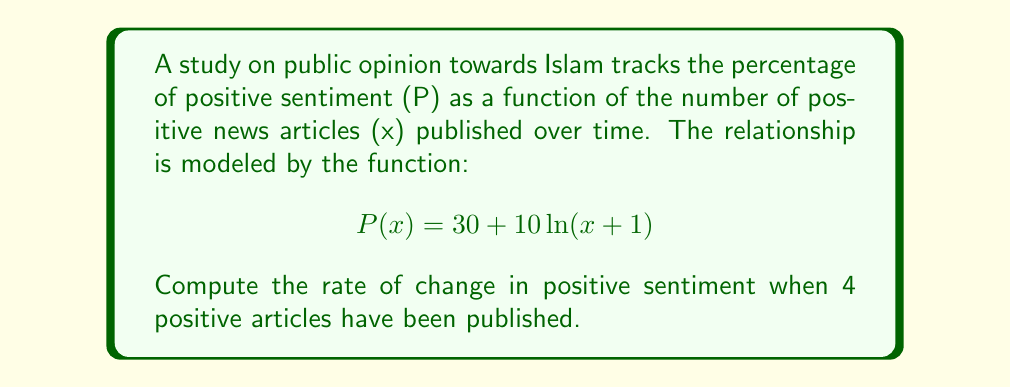Can you solve this math problem? To find the rate of change, we need to calculate the derivative of the function P(x) and then evaluate it at x = 4.

Step 1: Find the derivative of P(x)
$$\frac{d}{dx}[P(x)] = \frac{d}{dx}[30 + 10\ln(x+1)]$$
$$P'(x) = 0 + 10 \cdot \frac{1}{x+1}$$
$$P'(x) = \frac{10}{x+1}$$

Step 2: Evaluate P'(x) at x = 4
$$P'(4) = \frac{10}{4+1} = \frac{10}{5} = 2$$

Therefore, when 4 positive articles have been published, the rate of change in positive sentiment towards Islam is 2 percentage points per article.
Answer: $2$ percentage points per article 